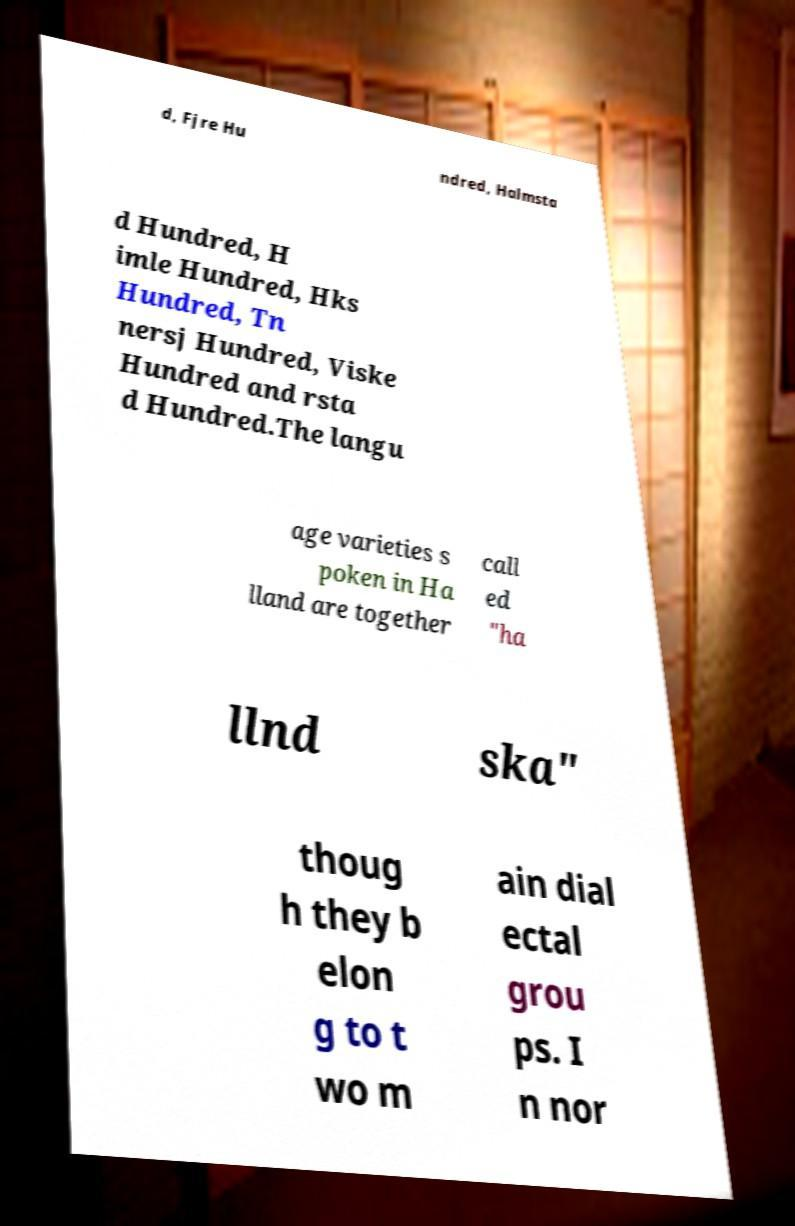Can you read and provide the text displayed in the image?This photo seems to have some interesting text. Can you extract and type it out for me? d, Fjre Hu ndred, Halmsta d Hundred, H imle Hundred, Hks Hundred, Tn nersj Hundred, Viske Hundred and rsta d Hundred.The langu age varieties s poken in Ha lland are together call ed "ha llnd ska" thoug h they b elon g to t wo m ain dial ectal grou ps. I n nor 